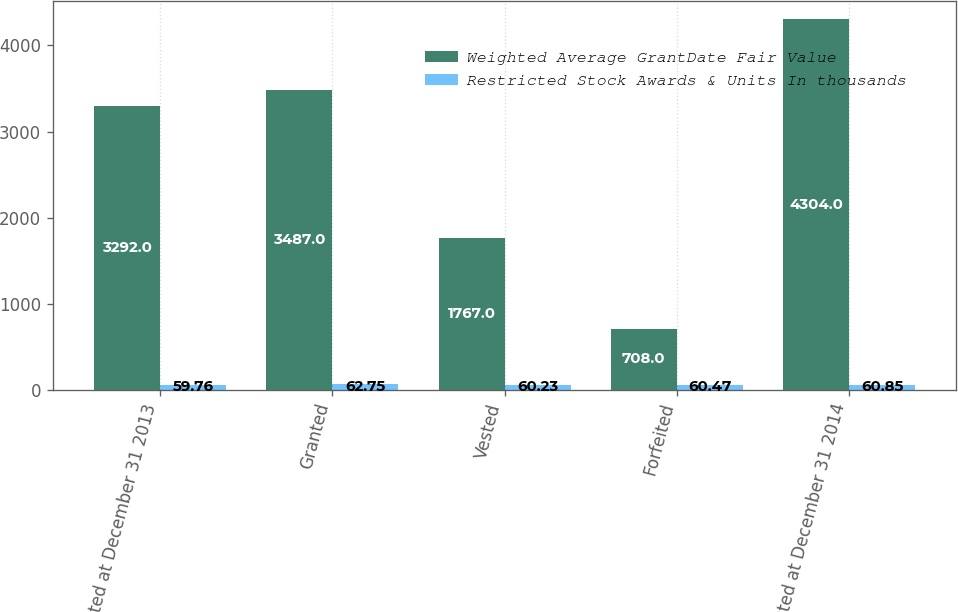Convert chart. <chart><loc_0><loc_0><loc_500><loc_500><stacked_bar_chart><ecel><fcel>Unvested at December 31 2013<fcel>Granted<fcel>Vested<fcel>Forfeited<fcel>Unvested at December 31 2014<nl><fcel>Weighted Average GrantDate Fair Value<fcel>3292<fcel>3487<fcel>1767<fcel>708<fcel>4304<nl><fcel>Restricted Stock Awards & Units In thousands<fcel>59.76<fcel>62.75<fcel>60.23<fcel>60.47<fcel>60.85<nl></chart> 